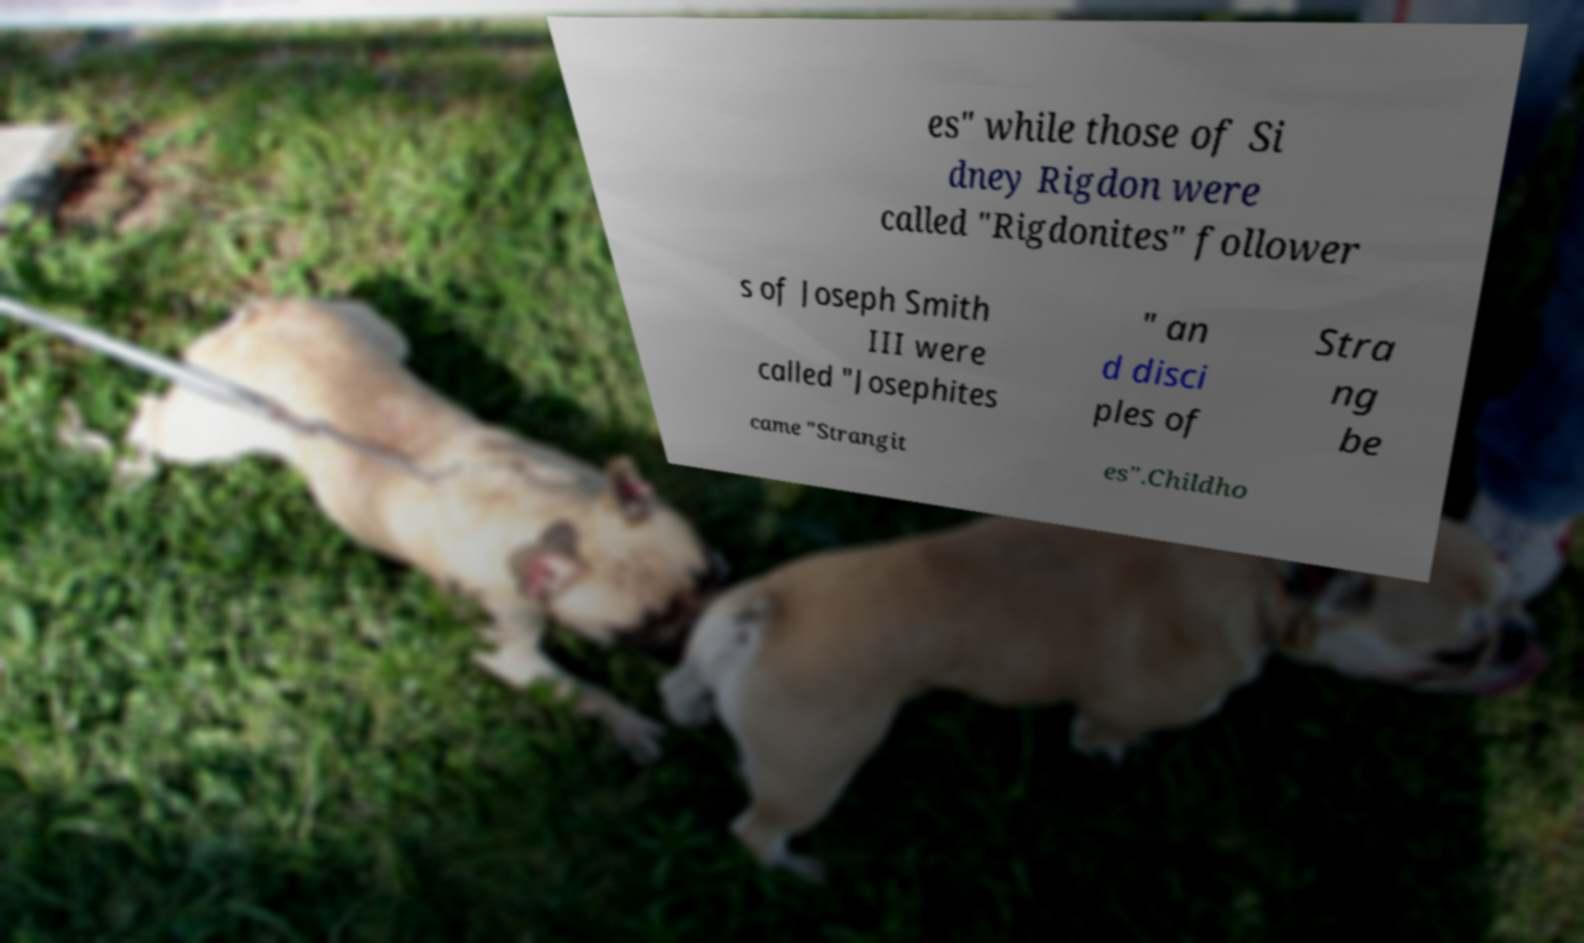Please identify and transcribe the text found in this image. es" while those of Si dney Rigdon were called "Rigdonites" follower s of Joseph Smith III were called "Josephites " an d disci ples of Stra ng be came "Strangit es".Childho 